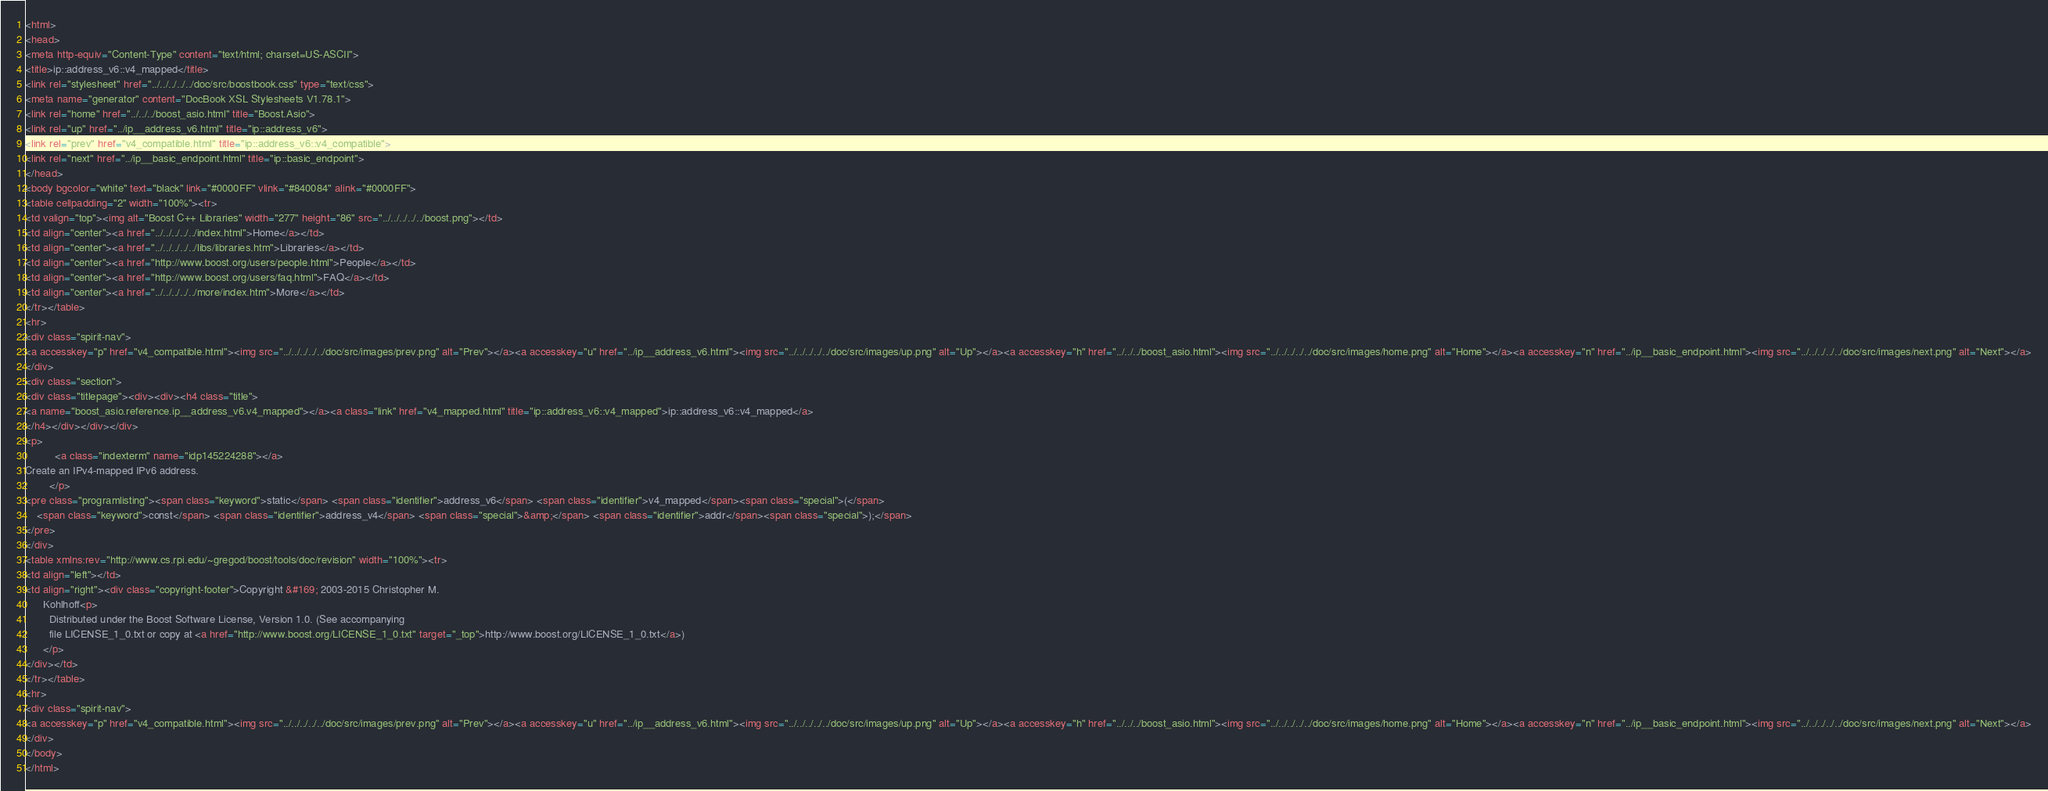<code> <loc_0><loc_0><loc_500><loc_500><_HTML_><html>
<head>
<meta http-equiv="Content-Type" content="text/html; charset=US-ASCII">
<title>ip::address_v6::v4_mapped</title>
<link rel="stylesheet" href="../../../../../doc/src/boostbook.css" type="text/css">
<meta name="generator" content="DocBook XSL Stylesheets V1.78.1">
<link rel="home" href="../../../boost_asio.html" title="Boost.Asio">
<link rel="up" href="../ip__address_v6.html" title="ip::address_v6">
<link rel="prev" href="v4_compatible.html" title="ip::address_v6::v4_compatible">
<link rel="next" href="../ip__basic_endpoint.html" title="ip::basic_endpoint">
</head>
<body bgcolor="white" text="black" link="#0000FF" vlink="#840084" alink="#0000FF">
<table cellpadding="2" width="100%"><tr>
<td valign="top"><img alt="Boost C++ Libraries" width="277" height="86" src="../../../../../boost.png"></td>
<td align="center"><a href="../../../../../index.html">Home</a></td>
<td align="center"><a href="../../../../../libs/libraries.htm">Libraries</a></td>
<td align="center"><a href="http://www.boost.org/users/people.html">People</a></td>
<td align="center"><a href="http://www.boost.org/users/faq.html">FAQ</a></td>
<td align="center"><a href="../../../../../more/index.htm">More</a></td>
</tr></table>
<hr>
<div class="spirit-nav">
<a accesskey="p" href="v4_compatible.html"><img src="../../../../../doc/src/images/prev.png" alt="Prev"></a><a accesskey="u" href="../ip__address_v6.html"><img src="../../../../../doc/src/images/up.png" alt="Up"></a><a accesskey="h" href="../../../boost_asio.html"><img src="../../../../../doc/src/images/home.png" alt="Home"></a><a accesskey="n" href="../ip__basic_endpoint.html"><img src="../../../../../doc/src/images/next.png" alt="Next"></a>
</div>
<div class="section">
<div class="titlepage"><div><div><h4 class="title">
<a name="boost_asio.reference.ip__address_v6.v4_mapped"></a><a class="link" href="v4_mapped.html" title="ip::address_v6::v4_mapped">ip::address_v6::v4_mapped</a>
</h4></div></div></div>
<p>
          <a class="indexterm" name="idp145224288"></a> 
Create an IPv4-mapped IPv6 address.
        </p>
<pre class="programlisting"><span class="keyword">static</span> <span class="identifier">address_v6</span> <span class="identifier">v4_mapped</span><span class="special">(</span>
    <span class="keyword">const</span> <span class="identifier">address_v4</span> <span class="special">&amp;</span> <span class="identifier">addr</span><span class="special">);</span>
</pre>
</div>
<table xmlns:rev="http://www.cs.rpi.edu/~gregod/boost/tools/doc/revision" width="100%"><tr>
<td align="left"></td>
<td align="right"><div class="copyright-footer">Copyright &#169; 2003-2015 Christopher M.
      Kohlhoff<p>
        Distributed under the Boost Software License, Version 1.0. (See accompanying
        file LICENSE_1_0.txt or copy at <a href="http://www.boost.org/LICENSE_1_0.txt" target="_top">http://www.boost.org/LICENSE_1_0.txt</a>)
      </p>
</div></td>
</tr></table>
<hr>
<div class="spirit-nav">
<a accesskey="p" href="v4_compatible.html"><img src="../../../../../doc/src/images/prev.png" alt="Prev"></a><a accesskey="u" href="../ip__address_v6.html"><img src="../../../../../doc/src/images/up.png" alt="Up"></a><a accesskey="h" href="../../../boost_asio.html"><img src="../../../../../doc/src/images/home.png" alt="Home"></a><a accesskey="n" href="../ip__basic_endpoint.html"><img src="../../../../../doc/src/images/next.png" alt="Next"></a>
</div>
</body>
</html>
</code> 